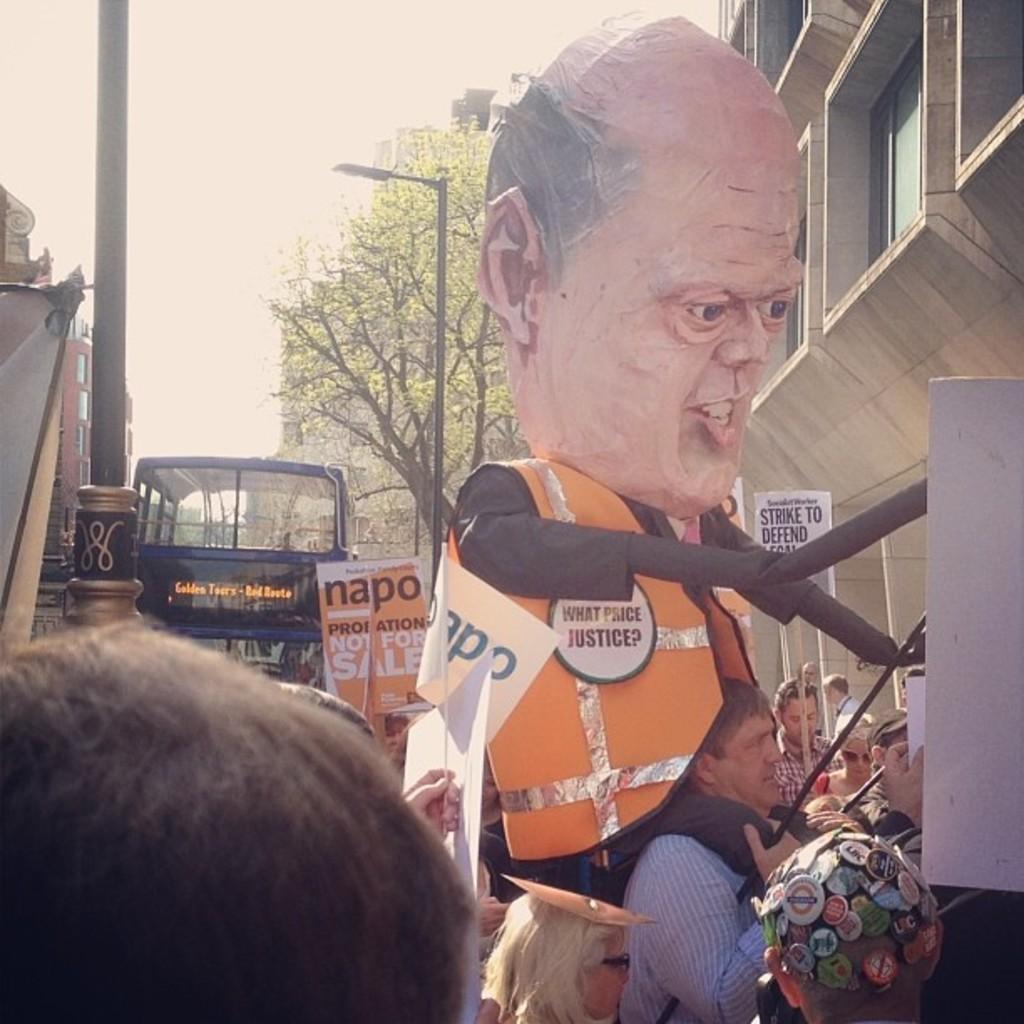How would you summarize this image in a sentence or two? Here people are standing, this is tree and a bus, this is a building and a sky. 